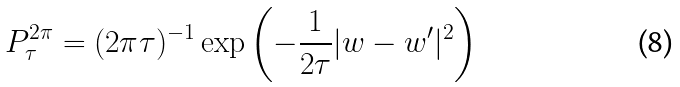Convert formula to latex. <formula><loc_0><loc_0><loc_500><loc_500>P _ { \tau } ^ { 2 \pi } = ( 2 \pi \tau ) ^ { - 1 } \exp \left ( - \frac { 1 } { 2 \tau } | w - w ^ { \prime } | ^ { 2 } \right )</formula> 